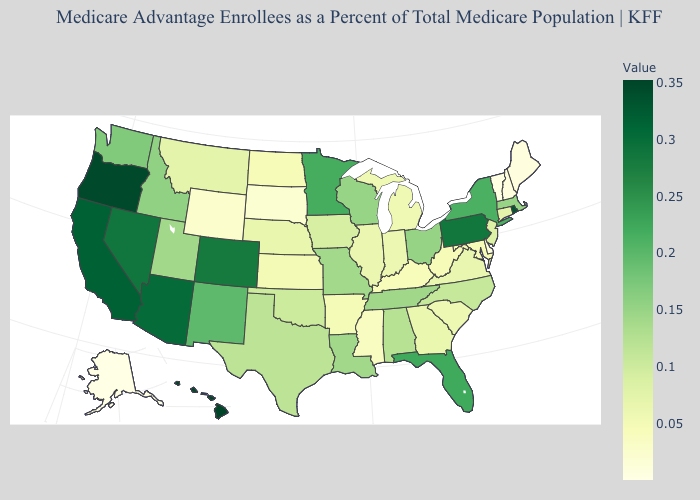Which states have the lowest value in the USA?
Short answer required. Alaska. Does Ohio have a higher value than New Mexico?
Short answer required. No. Among the states that border Virginia , does Kentucky have the lowest value?
Write a very short answer. Yes. 